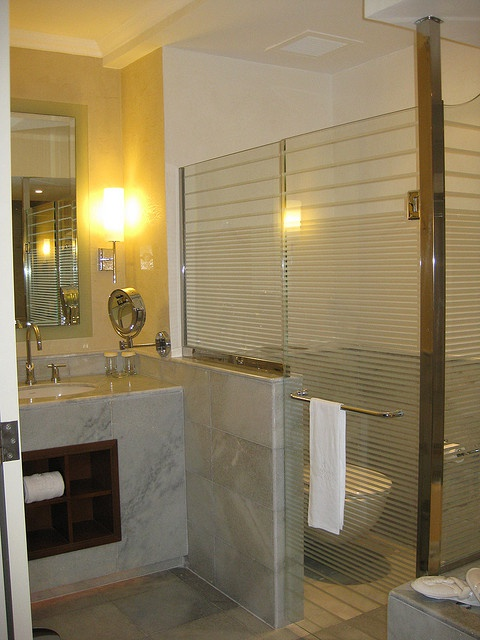Describe the objects in this image and their specific colors. I can see toilet in darkgray, gray, olive, and tan tones, sink in darkgray, tan, and gray tones, cup in darkgray, gray, olive, and tan tones, and cup in darkgray, gray, olive, and tan tones in this image. 